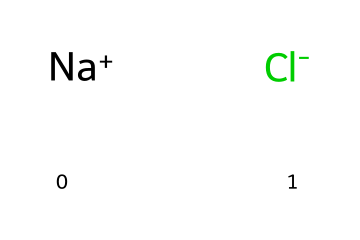What is the total number of atoms in this chemical structure? The chemical structure contains one sodium atom and one chlorine atom, which adds up to a total of two atoms.
Answer: two What are the charges of the ions in this chemical? The sodium ion has a positive charge ([Na+]), while the chloride ion has a negative charge ([Cl-]). This information is directly deduced from their representations.
Answer: positive and negative What is the chemical name of this compound? The chemical is commonly known as sodium chloride, which is its IUPAC name for the compound represented by the ions noted in the structure.
Answer: sodium chloride How many bonds are present in sodium chloride? In ionic compounds like sodium chloride, there are no traditional covalent bonds; instead, there is an ionic bond between the sodium ion and the chloride ion. Hence, considering it as a single bond interaction in this structure, we can denote the presence of one primary bond.
Answer: one What role does sodium chloride play in food products? Sodium chloride is primarily used as a flavor enhancer and preservative in food products, affecting taste and shelf life. This is a well-known property of table salt as depicted in various food chemistry contexts.
Answer: flavor enhancer Why does sodium chloride dissolve easily in water? The ionic nature of sodium chloride, with sodium ions and chloride ions having different charges, allows them to interact with water molecules effectively. The polar water molecules stabilize the separated ions, leading to easy dissolution.
Answer: ionic nature What type of chemical interaction is predominant in sodium chloride? The predominant interaction in sodium chloride is ionic bonding, which occurs between the positive and negative ions providing stability to the compound in its solid form.
Answer: ionic bonding 